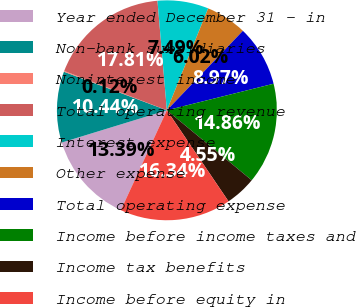<chart> <loc_0><loc_0><loc_500><loc_500><pie_chart><fcel>Year ended December 31 - in<fcel>Non-bank subsidiaries<fcel>Noninterest income<fcel>Total operating revenue<fcel>Interest expense<fcel>Other expense<fcel>Total operating expense<fcel>Income before income taxes and<fcel>Income tax benefits<fcel>Income before equity in<nl><fcel>13.39%<fcel>10.44%<fcel>0.12%<fcel>17.81%<fcel>7.49%<fcel>6.02%<fcel>8.97%<fcel>14.86%<fcel>4.55%<fcel>16.34%<nl></chart> 